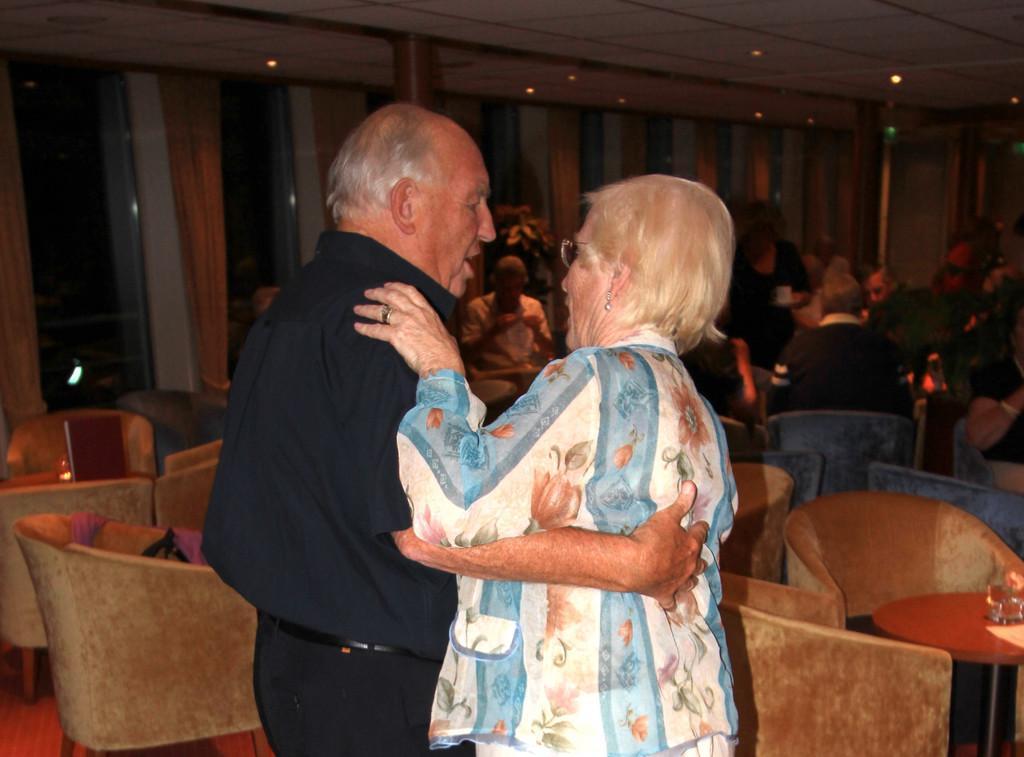Describe this image in one or two sentences. In Front portion of the picture we can see a man and a woman hugging each other. Behind to them we can see a table and on the table we can see glass. We can see all the persons sitting on chairs. At the top we can see ceiling and lights. These are door with curtains. 